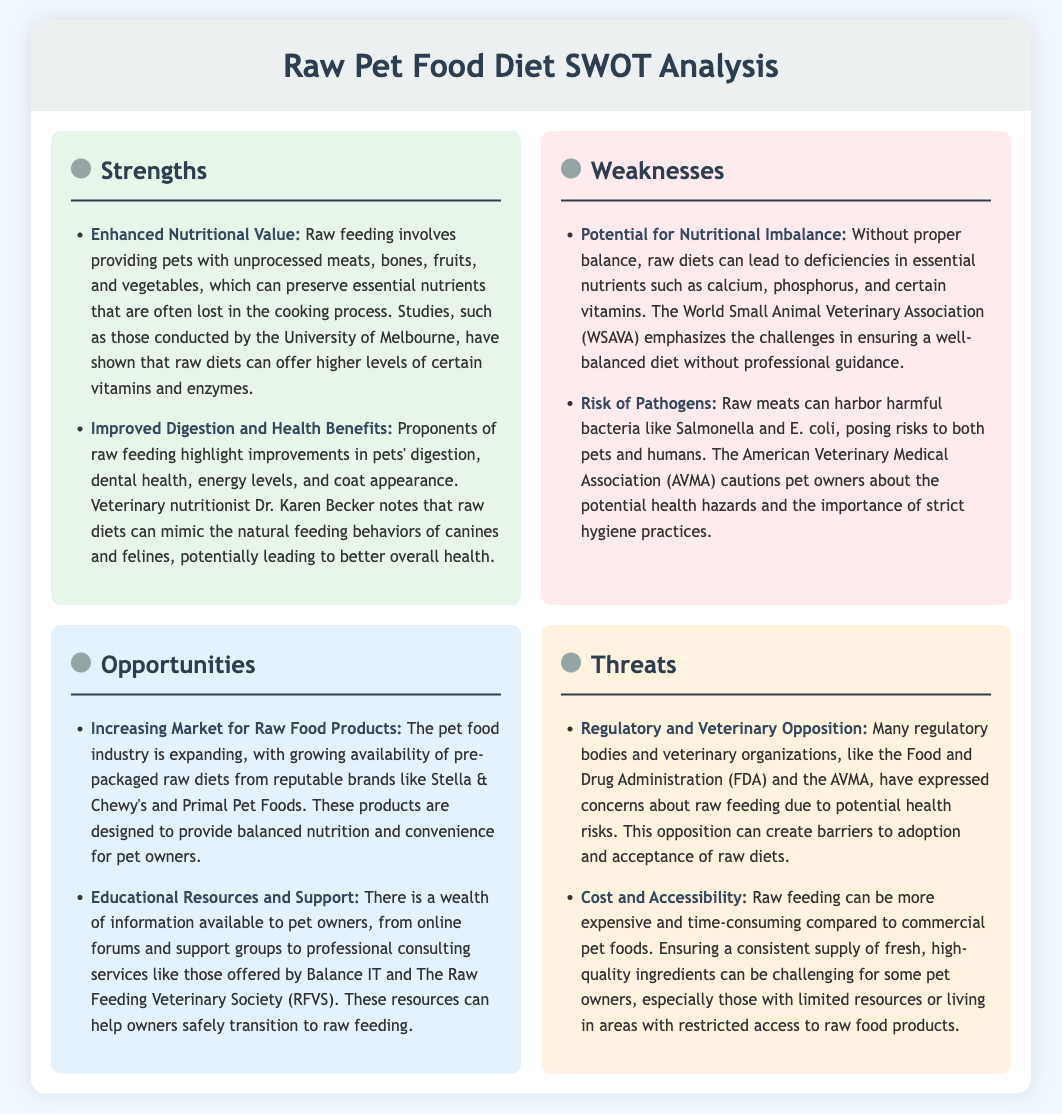what is one strength of a raw food diet? One strength mentioned in the document is enhanced nutritional value, as raw feeding preserves essential nutrients often lost in cooking.
Answer: enhanced nutritional value what is a potential weakness of a raw food diet? The document highlights potential for nutritional imbalance as a weakness, which can lead to deficiencies in essential nutrients.
Answer: potential for nutritional imbalance what is one opportunity for raw feeding? The document states that there is an increasing market for raw food products, offering convenience for pet owners.
Answer: increasing market for raw food products what is a noted threat to raw feeding? The document mentions regulatory and veterinary opposition as a threat to the adoption of raw diets.
Answer: regulatory and veterinary opposition how many strengths are listed in the document? The document includes two strengths regarding raw feeding.
Answer: 2 who conducted studies indicating the benefits of raw diets? Studies cited in the document were conducted by the University of Melbourne.
Answer: University of Melbourne which organization warns about the risks of pathogens in raw diets? The American Veterinary Medical Association (AVMA) warns about the health hazards of pathogens in raw diets.
Answer: American Veterinary Medical Association (AVMA) what does WSAVA emphasize regarding raw diets? WSAVA emphasizes the challenges in ensuring a well-balanced diet without professional guidance.
Answer: challenges in ensuring a well-balanced diet how can pet owners safely transition to raw feeding? The document mentions that educational resources and support are available to help pet owners transition safely to raw feeding.
Answer: educational resources and support 